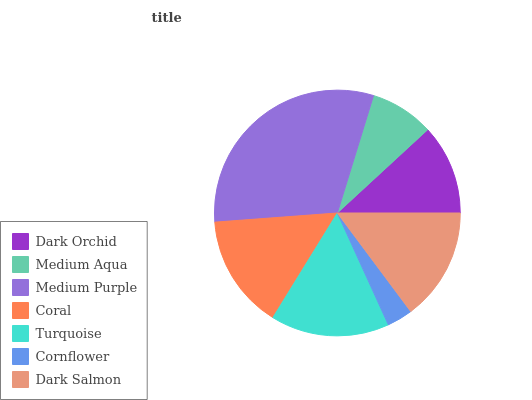Is Cornflower the minimum?
Answer yes or no. Yes. Is Medium Purple the maximum?
Answer yes or no. Yes. Is Medium Aqua the minimum?
Answer yes or no. No. Is Medium Aqua the maximum?
Answer yes or no. No. Is Dark Orchid greater than Medium Aqua?
Answer yes or no. Yes. Is Medium Aqua less than Dark Orchid?
Answer yes or no. Yes. Is Medium Aqua greater than Dark Orchid?
Answer yes or no. No. Is Dark Orchid less than Medium Aqua?
Answer yes or no. No. Is Dark Salmon the high median?
Answer yes or no. Yes. Is Dark Salmon the low median?
Answer yes or no. Yes. Is Medium Aqua the high median?
Answer yes or no. No. Is Dark Orchid the low median?
Answer yes or no. No. 